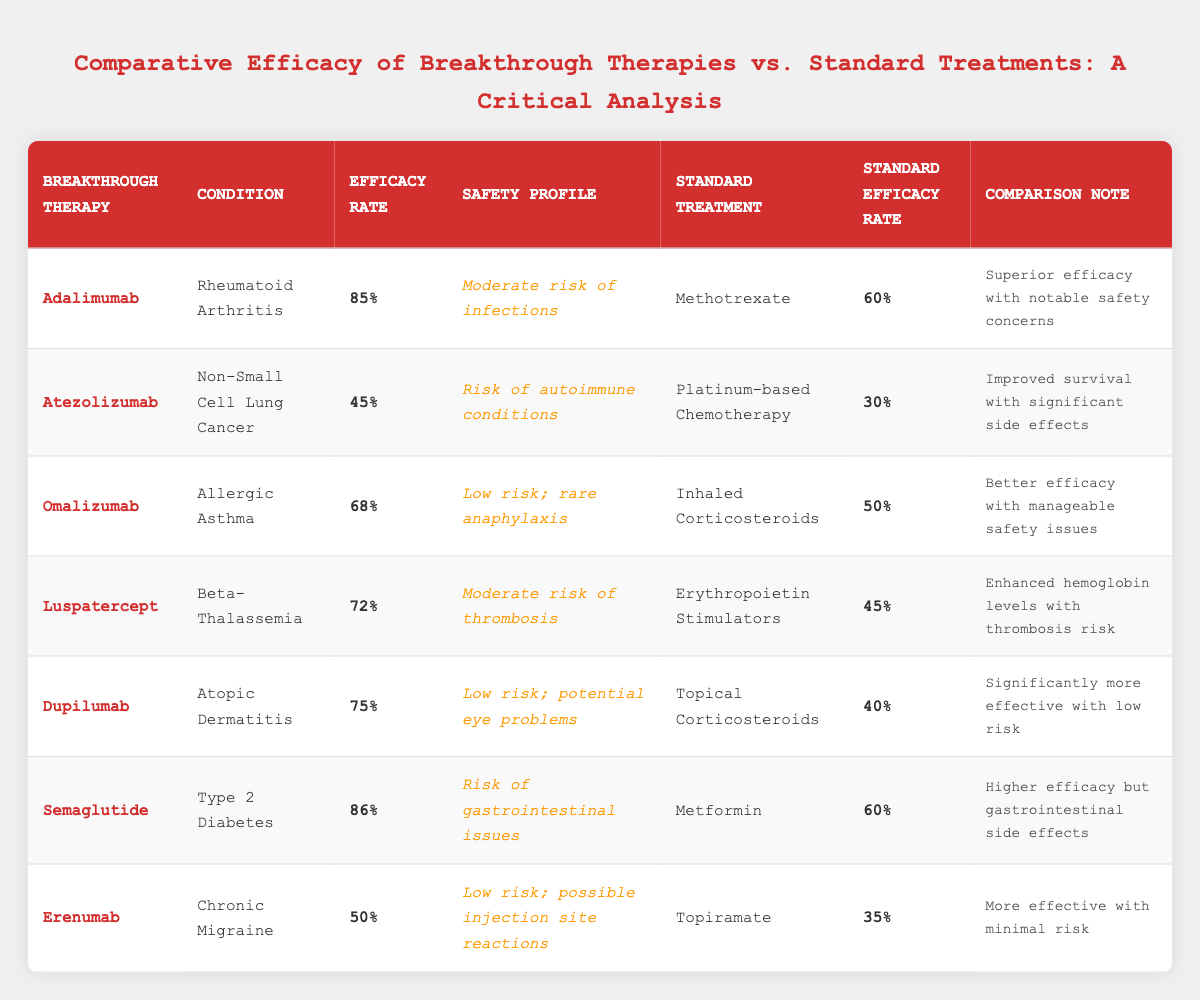What is the efficacy rate of Adalimumab? The efficacy rate for Adalimumab is directly stated in the table under the "Efficacy Rate" column for this therapy, which shows 85%.
Answer: 85% Which therapy has the highest efficacy rate? By examining the "Efficacy Rate" column for all therapies, Semaglutide has the highest rate at 86%.
Answer: Semaglutide What is the standard treatment for Non-Small Cell Lung Cancer? The table lists "Platinum-based Chemotherapy" as the standard treatment for the condition indicated under the "Standard Treatment" column for Atezolizumab.
Answer: Platinum-based Chemotherapy Is the safety profile of Omalizumab low or moderate risk? From the "Safety Profile" column, Omalizumab is categorized as having a "Low risk; rare anaphylaxis."
Answer: Low risk What is the difference in efficacy rates between Dupilumab and its standard treatment? The efficacy rate for Dupilumab is 75% and for the standard treatment, which is Topical Corticosteroids, it is 40%. The difference is 75% - 40% = 35%.
Answer: 35% What is the average efficacy rate of the breakthrough therapies listed? The efficacy rates of each therapy are 85, 45, 68, 72, 75, 86, and 50. Summing these gives 85 + 45 + 68 + 72 + 75 + 86 + 50 = 481. There are 7 therapies, so the average efficacy rate is 481/7 = 68.71%.
Answer: 68.71% Which therapy shows a higher risk of infections? The safety profile of Adalimumab mentions a "Moderate risk of infections," while other therapies like Omalizumab mention low risk. Therefore, Adalimumab has a higher risk.
Answer: Adalimumab What is the efficacy rate of the standard treatment for Type 2 Diabetes? The standard treatment for Type 2 Diabetes is Metformin, which has an efficacy rate stated in the table as 60%.
Answer: 60% Do both Atezolizumab and its standard treatment show efficacy rates above 40%? Atezolizumab has an efficacy rate of 45%, and its standard treatment, Platinum-based Chemotherapy, has an efficacy rate of 30%. Thus, Atezolizumab is above 40%, but the standard treatment is not.
Answer: No Considering efficacy and safety, which therapy risks thrombosis? The therapy Luspatercept for Beta-Thalassemia shows a "Moderate risk of thrombosis" in its safety profile, while other therapies have different risk profiles.
Answer: Luspatercept 